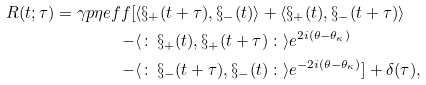Convert formula to latex. <formula><loc_0><loc_0><loc_500><loc_500>R ( t ; \tau ) = \gamma p \eta e f f [ & \langle \S _ { + } ( t + \tau ) , \S _ { - } ( t ) \rangle + \langle \S _ { + } ( t ) , \S _ { - } ( t + \tau ) \rangle \\ - & \langle \colon \, \S _ { + } ( t ) , \S _ { + } ( t + \tau ) \, \colon \rangle e ^ { 2 i ( \theta - \theta _ { \kappa } ) } \\ - & \langle \colon \, \S _ { - } ( t + \tau ) , \S _ { - } ( t ) \, \colon \rangle e ^ { - 2 i ( \theta - \theta _ { \kappa } ) } ] + \delta ( \tau ) ,</formula> 